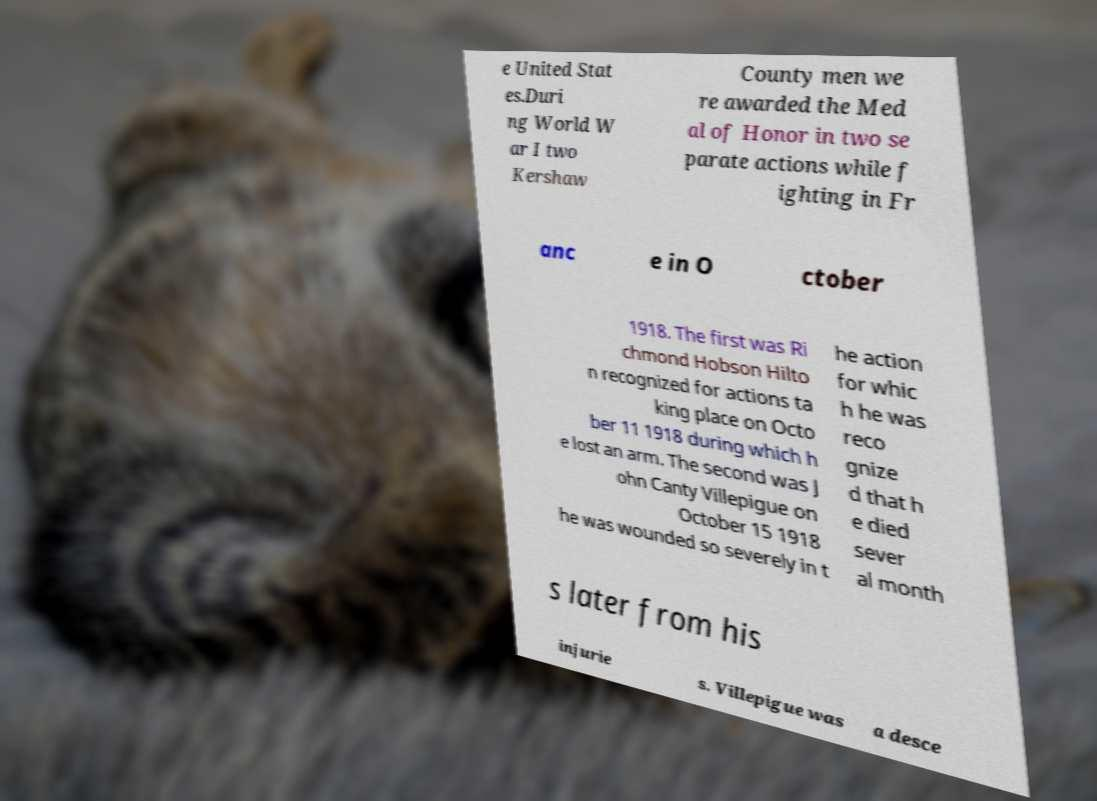Please read and relay the text visible in this image. What does it say? e United Stat es.Duri ng World W ar I two Kershaw County men we re awarded the Med al of Honor in two se parate actions while f ighting in Fr anc e in O ctober 1918. The first was Ri chmond Hobson Hilto n recognized for actions ta king place on Octo ber 11 1918 during which h e lost an arm. The second was J ohn Canty Villepigue on October 15 1918 he was wounded so severely in t he action for whic h he was reco gnize d that h e died sever al month s later from his injurie s. Villepigue was a desce 